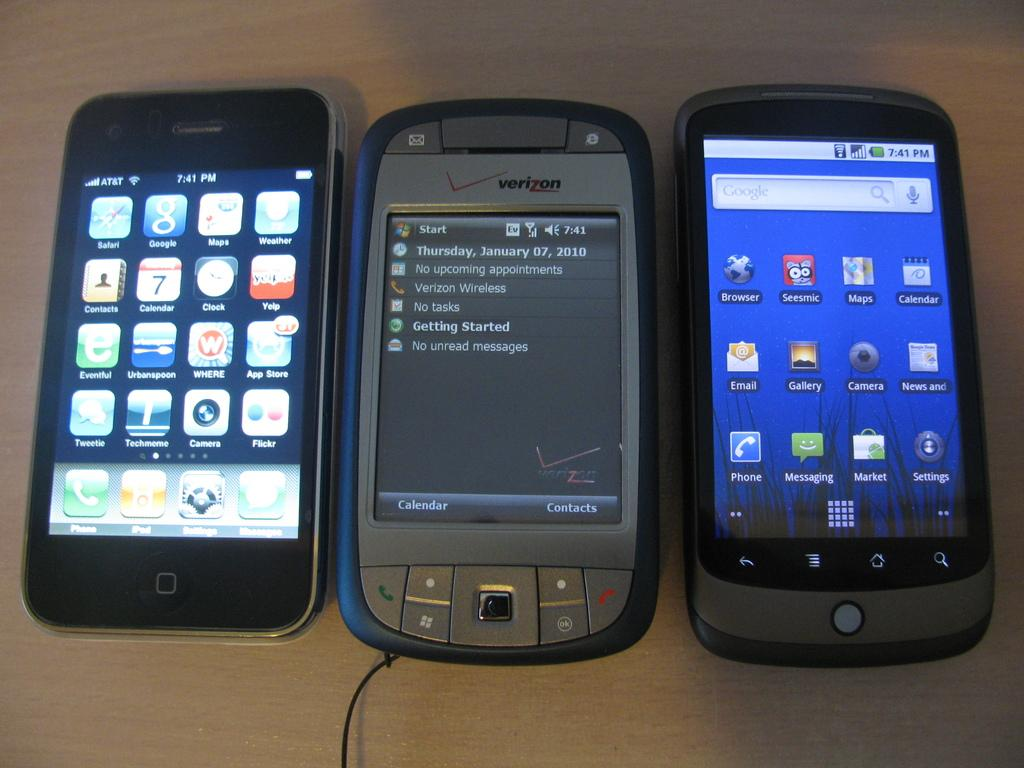<image>
Share a concise interpretation of the image provided. A group of three phones with the Verizon model in the middle displaying the Start menu. 